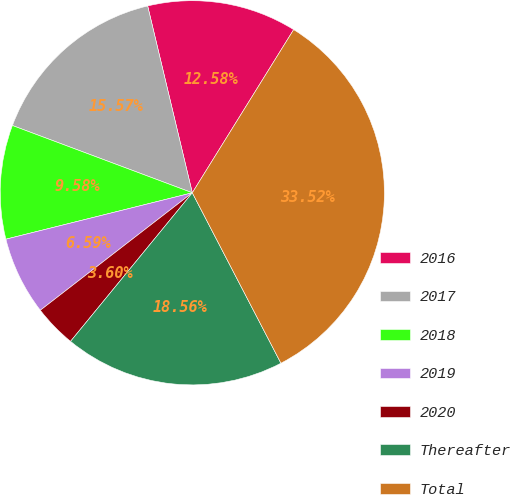Convert chart. <chart><loc_0><loc_0><loc_500><loc_500><pie_chart><fcel>2016<fcel>2017<fcel>2018<fcel>2019<fcel>2020<fcel>Thereafter<fcel>Total<nl><fcel>12.58%<fcel>15.57%<fcel>9.58%<fcel>6.59%<fcel>3.6%<fcel>18.56%<fcel>33.52%<nl></chart> 